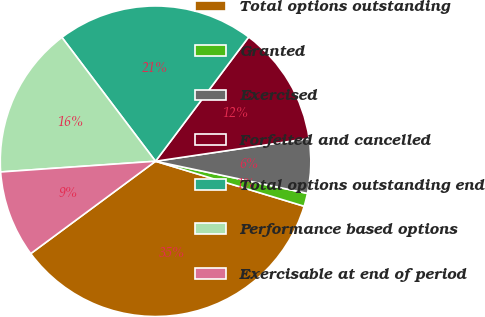Convert chart. <chart><loc_0><loc_0><loc_500><loc_500><pie_chart><fcel>Total options outstanding<fcel>Granted<fcel>Exercised<fcel>Forfeited and cancelled<fcel>Total options outstanding end<fcel>Performance based options<fcel>Exercisable at end of period<nl><fcel>35.18%<fcel>1.36%<fcel>5.66%<fcel>12.42%<fcel>20.54%<fcel>15.8%<fcel>9.04%<nl></chart> 